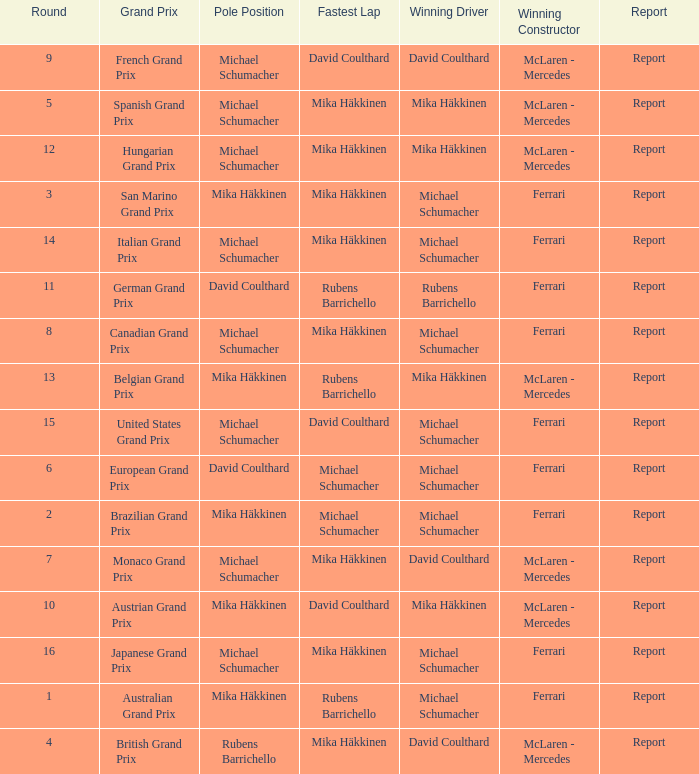How many drivers won the Italian Grand Prix? 1.0. Would you mind parsing the complete table? {'header': ['Round', 'Grand Prix', 'Pole Position', 'Fastest Lap', 'Winning Driver', 'Winning Constructor', 'Report'], 'rows': [['9', 'French Grand Prix', 'Michael Schumacher', 'David Coulthard', 'David Coulthard', 'McLaren - Mercedes', 'Report'], ['5', 'Spanish Grand Prix', 'Michael Schumacher', 'Mika Häkkinen', 'Mika Häkkinen', 'McLaren - Mercedes', 'Report'], ['12', 'Hungarian Grand Prix', 'Michael Schumacher', 'Mika Häkkinen', 'Mika Häkkinen', 'McLaren - Mercedes', 'Report'], ['3', 'San Marino Grand Prix', 'Mika Häkkinen', 'Mika Häkkinen', 'Michael Schumacher', 'Ferrari', 'Report'], ['14', 'Italian Grand Prix', 'Michael Schumacher', 'Mika Häkkinen', 'Michael Schumacher', 'Ferrari', 'Report'], ['11', 'German Grand Prix', 'David Coulthard', 'Rubens Barrichello', 'Rubens Barrichello', 'Ferrari', 'Report'], ['8', 'Canadian Grand Prix', 'Michael Schumacher', 'Mika Häkkinen', 'Michael Schumacher', 'Ferrari', 'Report'], ['13', 'Belgian Grand Prix', 'Mika Häkkinen', 'Rubens Barrichello', 'Mika Häkkinen', 'McLaren - Mercedes', 'Report'], ['15', 'United States Grand Prix', 'Michael Schumacher', 'David Coulthard', 'Michael Schumacher', 'Ferrari', 'Report'], ['6', 'European Grand Prix', 'David Coulthard', 'Michael Schumacher', 'Michael Schumacher', 'Ferrari', 'Report'], ['2', 'Brazilian Grand Prix', 'Mika Häkkinen', 'Michael Schumacher', 'Michael Schumacher', 'Ferrari', 'Report'], ['7', 'Monaco Grand Prix', 'Michael Schumacher', 'Mika Häkkinen', 'David Coulthard', 'McLaren - Mercedes', 'Report'], ['10', 'Austrian Grand Prix', 'Mika Häkkinen', 'David Coulthard', 'Mika Häkkinen', 'McLaren - Mercedes', 'Report'], ['16', 'Japanese Grand Prix', 'Michael Schumacher', 'Mika Häkkinen', 'Michael Schumacher', 'Ferrari', 'Report'], ['1', 'Australian Grand Prix', 'Mika Häkkinen', 'Rubens Barrichello', 'Michael Schumacher', 'Ferrari', 'Report'], ['4', 'British Grand Prix', 'Rubens Barrichello', 'Mika Häkkinen', 'David Coulthard', 'McLaren - Mercedes', 'Report']]} 